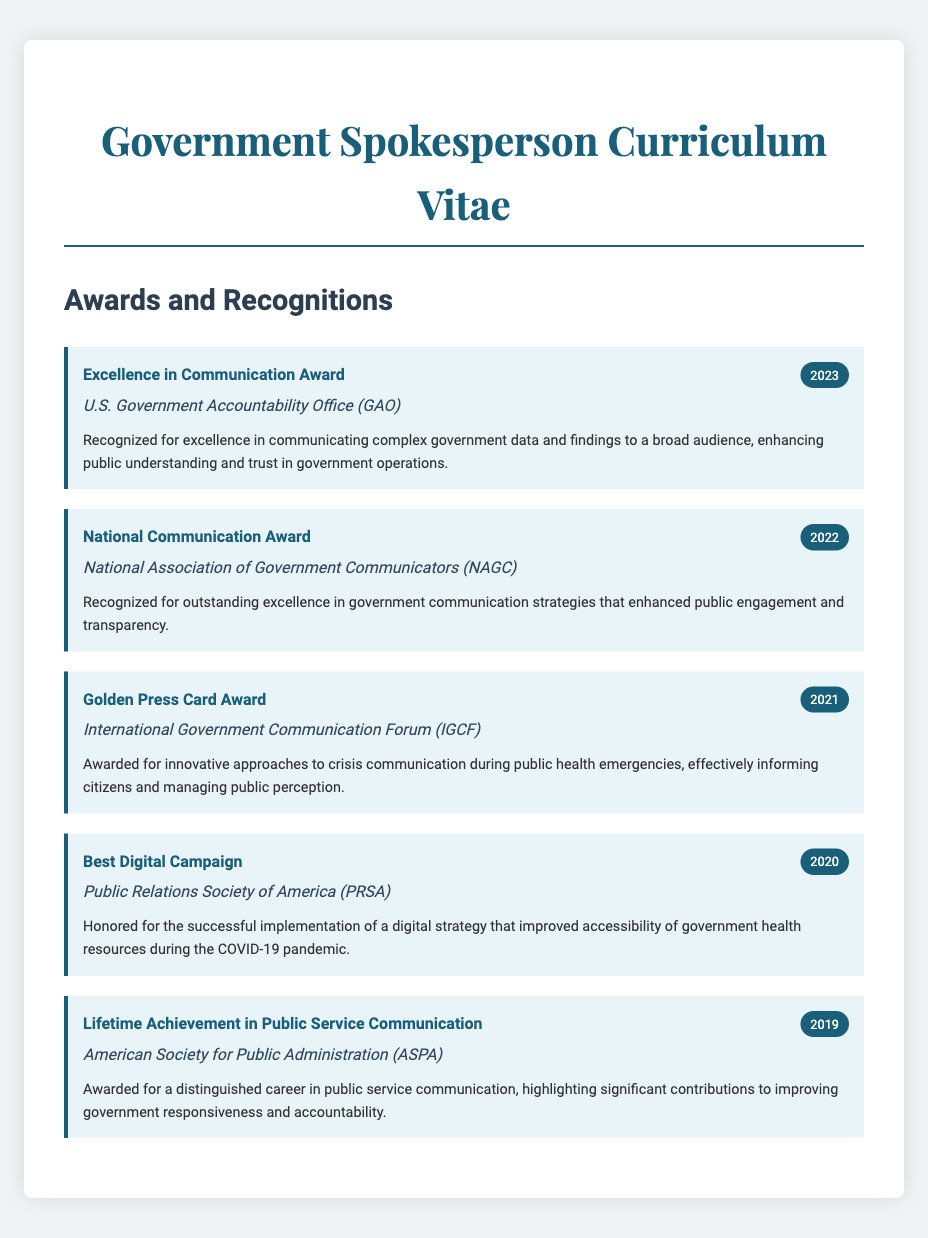what is the title of the award received in 2023? The title of the award received in 2023 is listed in the document under the awards section.
Answer: Excellence in Communication Award who awarded the National Communication Award in 2022? The organization that awarded the National Communication Award in 2022 is mentioned next to the award title.
Answer: National Association of Government Communicators (NAGC) what year was the Golden Press Card Award received? The year in which the Golden Press Card Award was received can be found beside the award title.
Answer: 2021 which award focuses on crisis communication? This award specifically addresses innovative approaches to crisis communication during public health emergencies, as described in the award details.
Answer: Golden Press Card Award who received the Lifetime Achievement in Public Service Communication? This award recognizes an individual for their significant contributions in public service communication.
Answer: (The answer is not a specific name; the document indicates "Lifetime Achievement in Public Service Communication" without specifying a name.) how many awards are listed in the document? The total number of awards can be counted from the individual award sections presented in the document.
Answer: 5 what is the main achievement recognized by the Best Digital Campaign award? The description of the award states the specific achievement it recognizes.
Answer: Successful implementation of a digital strategy what is the description given for the Excellence in Communication Award? This description details what the award was for and what it recognized in the realm of government communication.
Answer: Recognized for excellence in communicating complex government data and findings to a broad audience 